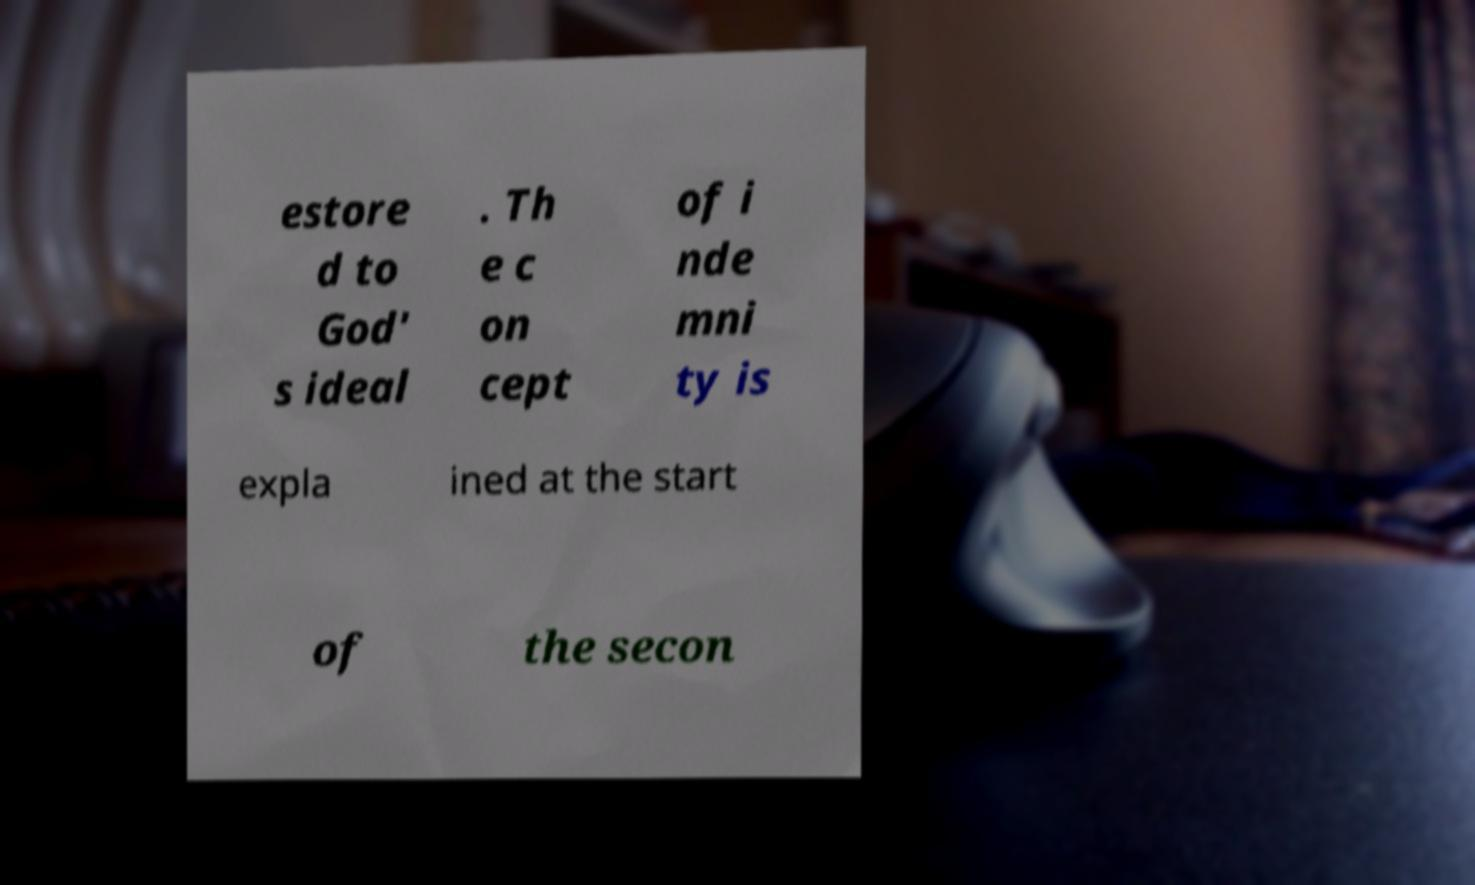I need the written content from this picture converted into text. Can you do that? estore d to God' s ideal . Th e c on cept of i nde mni ty is expla ined at the start of the secon 